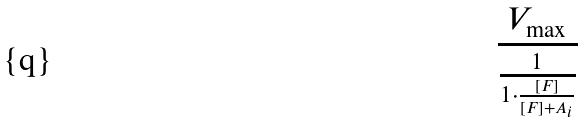Convert formula to latex. <formula><loc_0><loc_0><loc_500><loc_500>\frac { V _ { \max } } { \frac { 1 } { 1 \cdot \frac { [ F ] } { [ F ] + A _ { i } } } }</formula> 